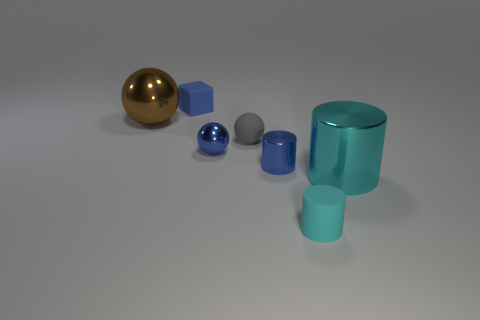The tiny block that is the same material as the tiny cyan object is what color?
Your answer should be very brief. Blue. There is a shiny thing that is in front of the small blue shiny sphere and to the left of the cyan shiny cylinder; how big is it?
Provide a short and direct response. Small. Is the number of small gray rubber things that are left of the gray rubber sphere less than the number of large cylinders that are behind the big brown shiny thing?
Offer a very short reply. No. Are the small blue thing on the right side of the gray ball and the big object that is on the right side of the small blue rubber block made of the same material?
Make the answer very short. Yes. There is a cylinder that is the same color as the matte block; what is it made of?
Provide a succinct answer. Metal. There is a object that is both behind the rubber ball and on the right side of the brown ball; what shape is it?
Keep it short and to the point. Cube. What is the small blue thing behind the metal object to the left of the blue rubber thing made of?
Your answer should be compact. Rubber. Is the number of cyan matte things greater than the number of purple metal things?
Give a very brief answer. Yes. Is the color of the small metal ball the same as the matte cylinder?
Your answer should be compact. No. There is a cyan thing that is the same size as the brown shiny thing; what is its material?
Provide a succinct answer. Metal. 